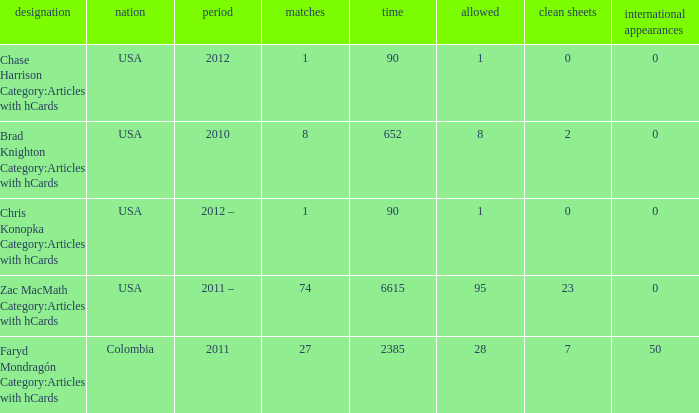When 2010 is the year what is the game? 8.0. 